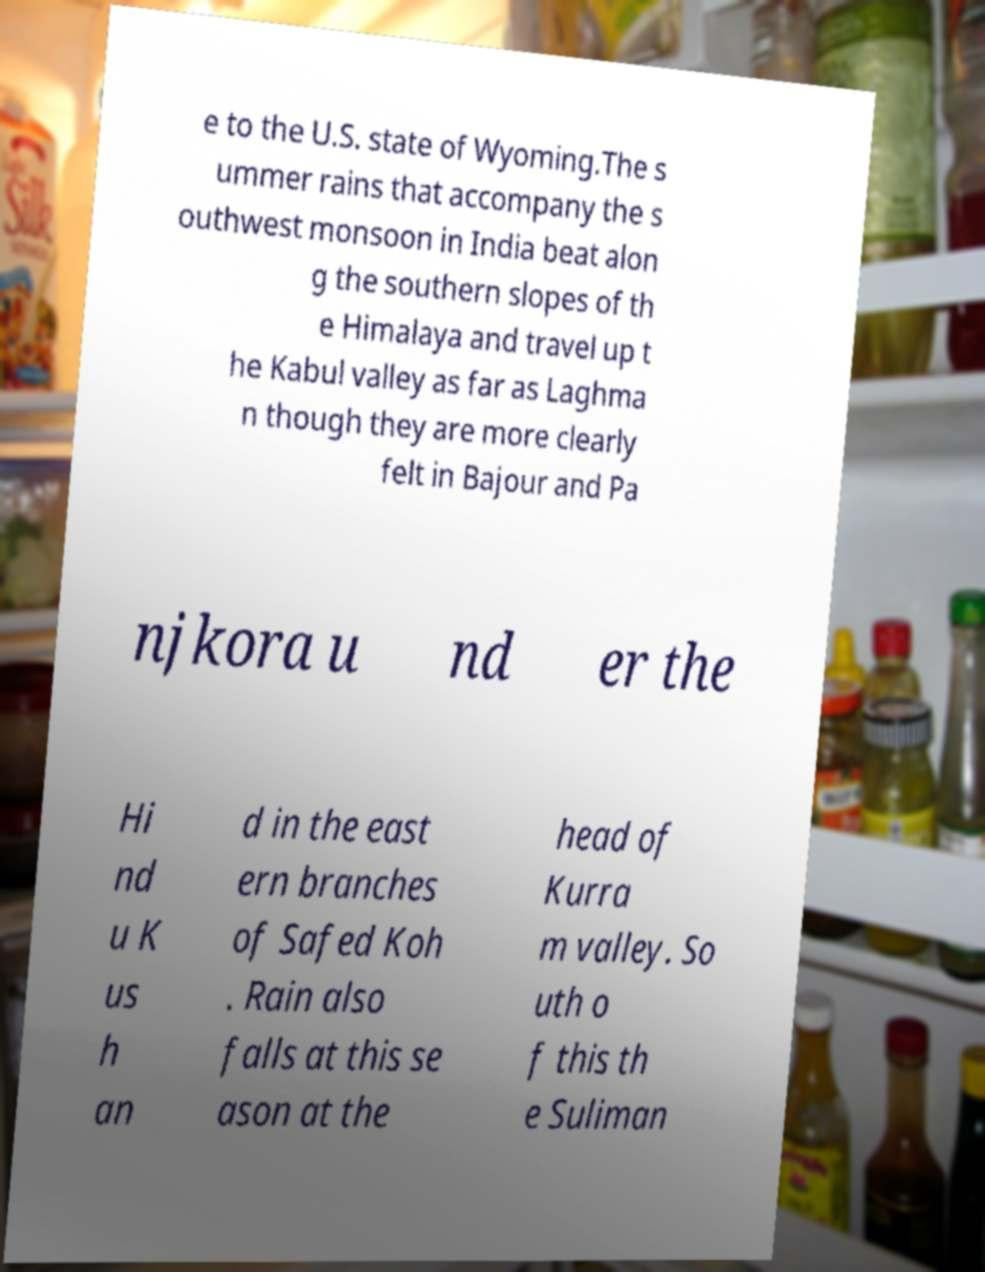Please identify and transcribe the text found in this image. e to the U.S. state of Wyoming.The s ummer rains that accompany the s outhwest monsoon in India beat alon g the southern slopes of th e Himalaya and travel up t he Kabul valley as far as Laghma n though they are more clearly felt in Bajour and Pa njkora u nd er the Hi nd u K us h an d in the east ern branches of Safed Koh . Rain also falls at this se ason at the head of Kurra m valley. So uth o f this th e Suliman 